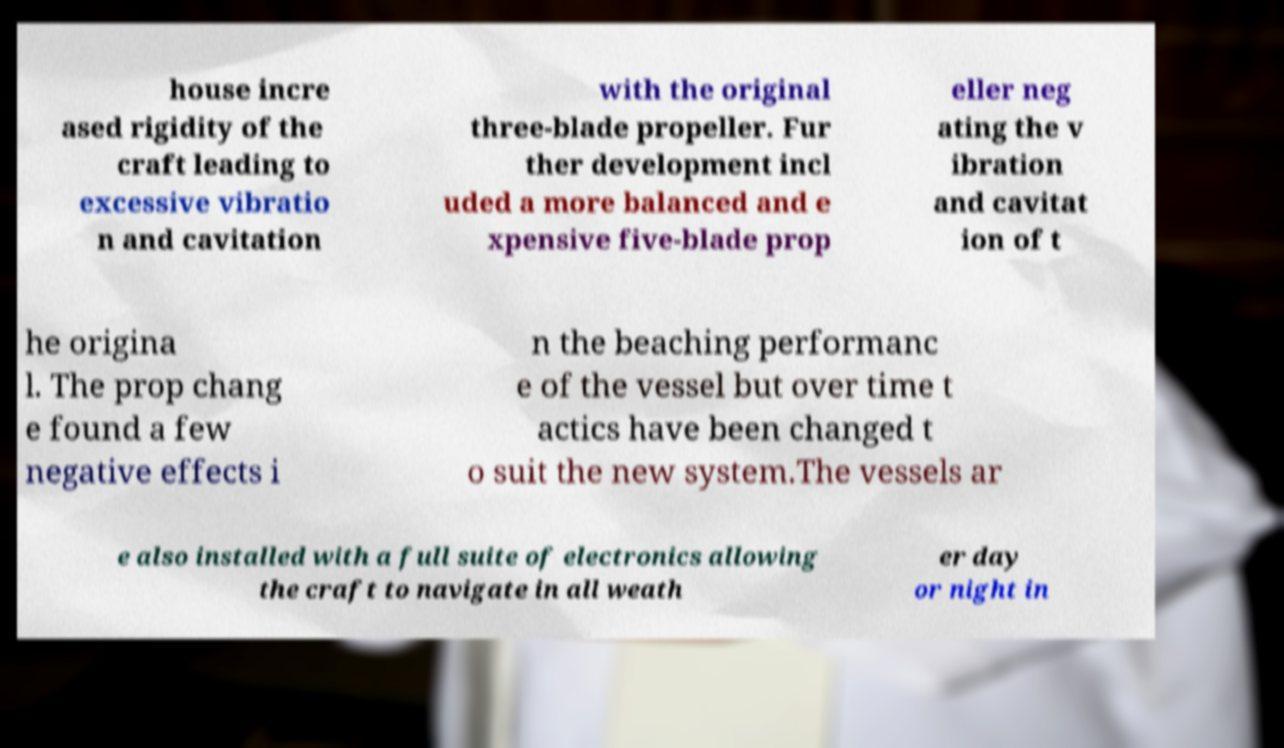I need the written content from this picture converted into text. Can you do that? house incre ased rigidity of the craft leading to excessive vibratio n and cavitation with the original three-blade propeller. Fur ther development incl uded a more balanced and e xpensive five-blade prop eller neg ating the v ibration and cavitat ion of t he origina l. The prop chang e found a few negative effects i n the beaching performanc e of the vessel but over time t actics have been changed t o suit the new system.The vessels ar e also installed with a full suite of electronics allowing the craft to navigate in all weath er day or night in 